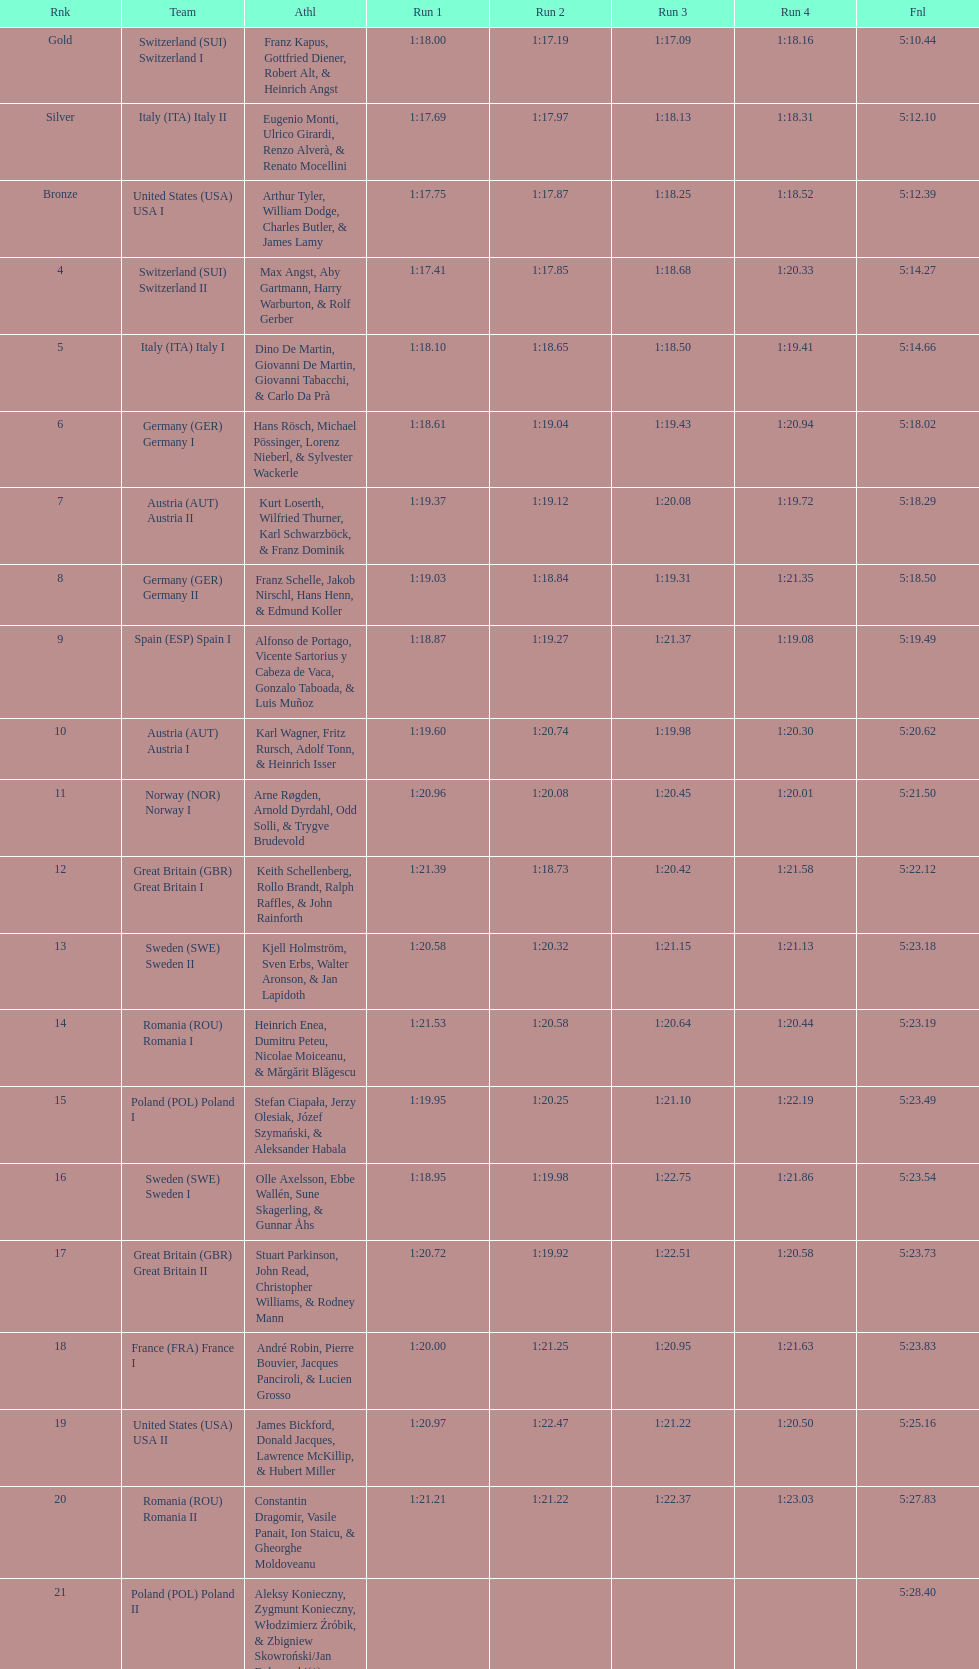Which team had the most time? Poland. Parse the table in full. {'header': ['Rnk', 'Team', 'Athl', 'Run 1', 'Run 2', 'Run 3', 'Run 4', 'Fnl'], 'rows': [['Gold', 'Switzerland\xa0(SUI) Switzerland I', 'Franz Kapus, Gottfried Diener, Robert Alt, & Heinrich Angst', '1:18.00', '1:17.19', '1:17.09', '1:18.16', '5:10.44'], ['Silver', 'Italy\xa0(ITA) Italy II', 'Eugenio Monti, Ulrico Girardi, Renzo Alverà, & Renato Mocellini', '1:17.69', '1:17.97', '1:18.13', '1:18.31', '5:12.10'], ['Bronze', 'United States\xa0(USA) USA I', 'Arthur Tyler, William Dodge, Charles Butler, & James Lamy', '1:17.75', '1:17.87', '1:18.25', '1:18.52', '5:12.39'], ['4', 'Switzerland\xa0(SUI) Switzerland II', 'Max Angst, Aby Gartmann, Harry Warburton, & Rolf Gerber', '1:17.41', '1:17.85', '1:18.68', '1:20.33', '5:14.27'], ['5', 'Italy\xa0(ITA) Italy I', 'Dino De Martin, Giovanni De Martin, Giovanni Tabacchi, & Carlo Da Prà', '1:18.10', '1:18.65', '1:18.50', '1:19.41', '5:14.66'], ['6', 'Germany\xa0(GER) Germany I', 'Hans Rösch, Michael Pössinger, Lorenz Nieberl, & Sylvester Wackerle', '1:18.61', '1:19.04', '1:19.43', '1:20.94', '5:18.02'], ['7', 'Austria\xa0(AUT) Austria II', 'Kurt Loserth, Wilfried Thurner, Karl Schwarzböck, & Franz Dominik', '1:19.37', '1:19.12', '1:20.08', '1:19.72', '5:18.29'], ['8', 'Germany\xa0(GER) Germany II', 'Franz Schelle, Jakob Nirschl, Hans Henn, & Edmund Koller', '1:19.03', '1:18.84', '1:19.31', '1:21.35', '5:18.50'], ['9', 'Spain\xa0(ESP) Spain I', 'Alfonso de Portago, Vicente Sartorius y Cabeza de Vaca, Gonzalo Taboada, & Luis Muñoz', '1:18.87', '1:19.27', '1:21.37', '1:19.08', '5:19.49'], ['10', 'Austria\xa0(AUT) Austria I', 'Karl Wagner, Fritz Rursch, Adolf Tonn, & Heinrich Isser', '1:19.60', '1:20.74', '1:19.98', '1:20.30', '5:20.62'], ['11', 'Norway\xa0(NOR) Norway I', 'Arne Røgden, Arnold Dyrdahl, Odd Solli, & Trygve Brudevold', '1:20.96', '1:20.08', '1:20.45', '1:20.01', '5:21.50'], ['12', 'Great Britain\xa0(GBR) Great Britain I', 'Keith Schellenberg, Rollo Brandt, Ralph Raffles, & John Rainforth', '1:21.39', '1:18.73', '1:20.42', '1:21.58', '5:22.12'], ['13', 'Sweden\xa0(SWE) Sweden II', 'Kjell Holmström, Sven Erbs, Walter Aronson, & Jan Lapidoth', '1:20.58', '1:20.32', '1:21.15', '1:21.13', '5:23.18'], ['14', 'Romania\xa0(ROU) Romania I', 'Heinrich Enea, Dumitru Peteu, Nicolae Moiceanu, & Mărgărit Blăgescu', '1:21.53', '1:20.58', '1:20.64', '1:20.44', '5:23.19'], ['15', 'Poland\xa0(POL) Poland I', 'Stefan Ciapała, Jerzy Olesiak, Józef Szymański, & Aleksander Habala', '1:19.95', '1:20.25', '1:21.10', '1:22.19', '5:23.49'], ['16', 'Sweden\xa0(SWE) Sweden I', 'Olle Axelsson, Ebbe Wallén, Sune Skagerling, & Gunnar Åhs', '1:18.95', '1:19.98', '1:22.75', '1:21.86', '5:23.54'], ['17', 'Great Britain\xa0(GBR) Great Britain II', 'Stuart Parkinson, John Read, Christopher Williams, & Rodney Mann', '1:20.72', '1:19.92', '1:22.51', '1:20.58', '5:23.73'], ['18', 'France\xa0(FRA) France I', 'André Robin, Pierre Bouvier, Jacques Panciroli, & Lucien Grosso', '1:20.00', '1:21.25', '1:20.95', '1:21.63', '5:23.83'], ['19', 'United States\xa0(USA) USA II', 'James Bickford, Donald Jacques, Lawrence McKillip, & Hubert Miller', '1:20.97', '1:22.47', '1:21.22', '1:20.50', '5:25.16'], ['20', 'Romania\xa0(ROU) Romania II', 'Constantin Dragomir, Vasile Panait, Ion Staicu, & Gheorghe Moldoveanu', '1:21.21', '1:21.22', '1:22.37', '1:23.03', '5:27.83'], ['21', 'Poland\xa0(POL) Poland II', 'Aleksy Konieczny, Zygmunt Konieczny, Włodzimierz Źróbik, & Zbigniew Skowroński/Jan Dąbrowski(*)', '', '', '', '', '5:28.40']]} 